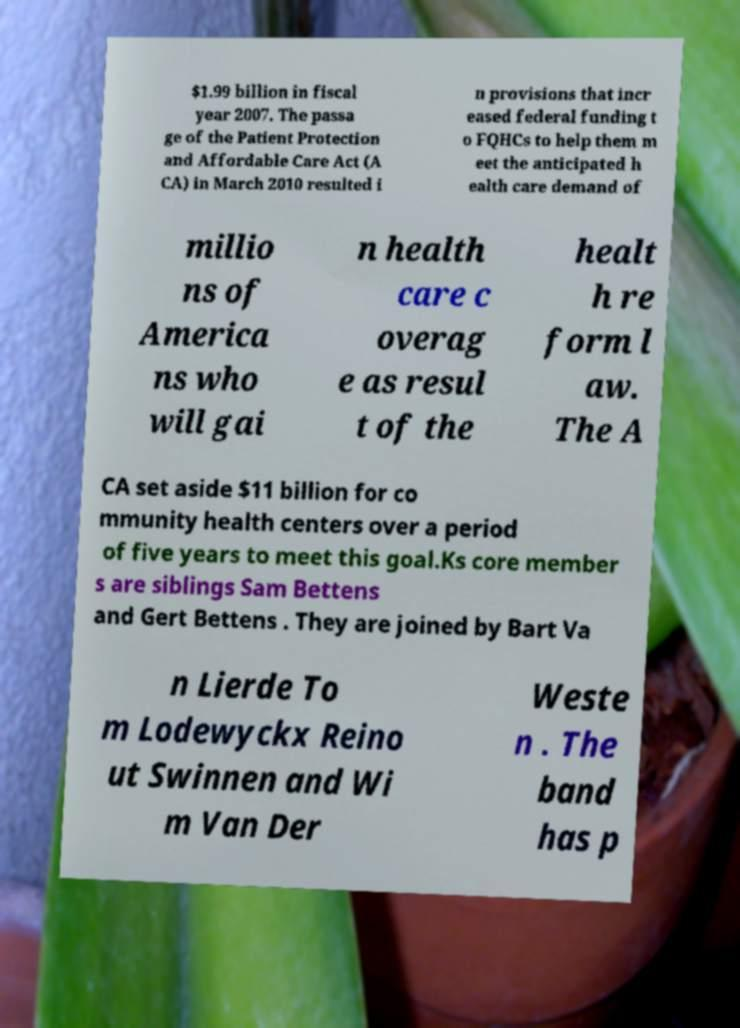Can you read and provide the text displayed in the image?This photo seems to have some interesting text. Can you extract and type it out for me? $1.99 billion in fiscal year 2007. The passa ge of the Patient Protection and Affordable Care Act (A CA) in March 2010 resulted i n provisions that incr eased federal funding t o FQHCs to help them m eet the anticipated h ealth care demand of millio ns of America ns who will gai n health care c overag e as resul t of the healt h re form l aw. The A CA set aside $11 billion for co mmunity health centers over a period of five years to meet this goal.Ks core member s are siblings Sam Bettens and Gert Bettens . They are joined by Bart Va n Lierde To m Lodewyckx Reino ut Swinnen and Wi m Van Der Weste n . The band has p 